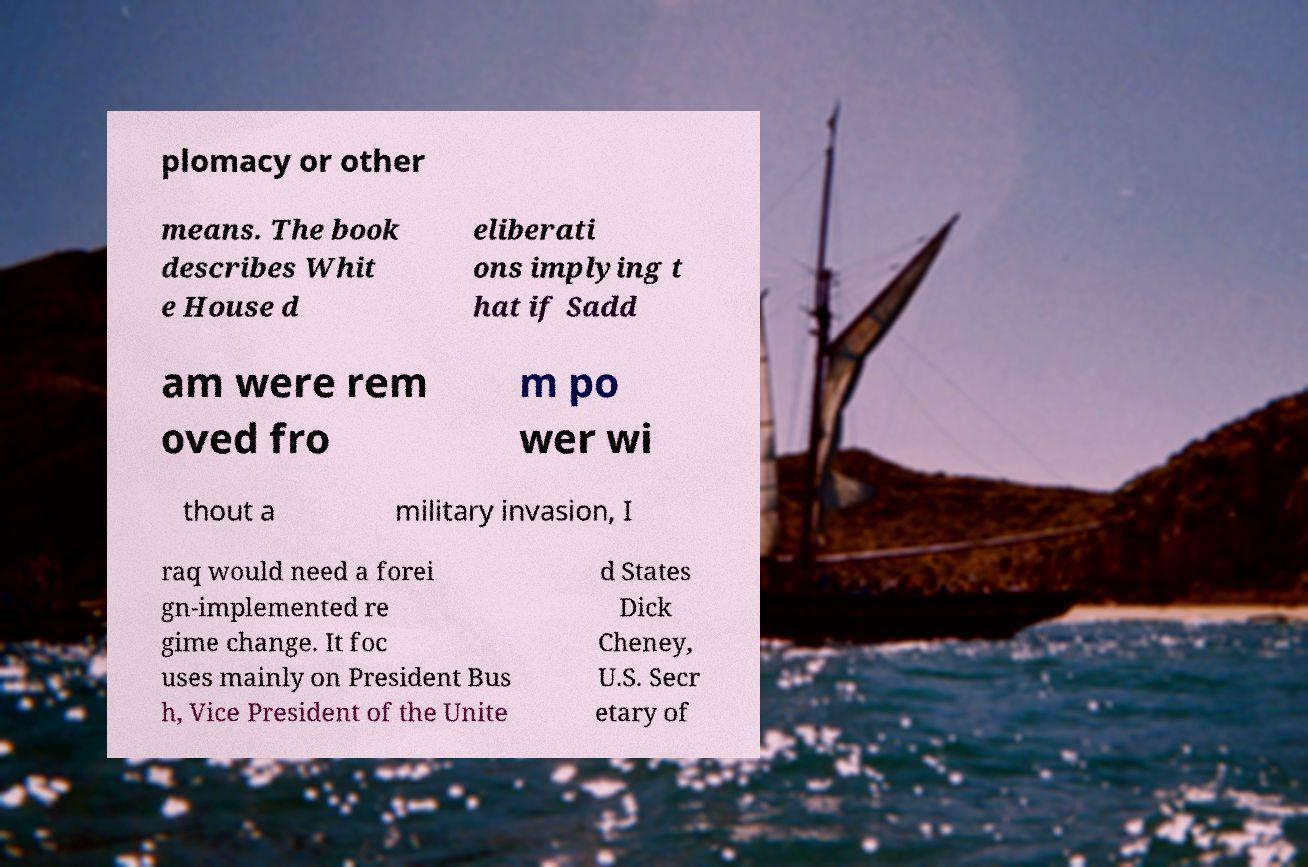Please identify and transcribe the text found in this image. plomacy or other means. The book describes Whit e House d eliberati ons implying t hat if Sadd am were rem oved fro m po wer wi thout a military invasion, I raq would need a forei gn-implemented re gime change. It foc uses mainly on President Bus h, Vice President of the Unite d States Dick Cheney, U.S. Secr etary of 